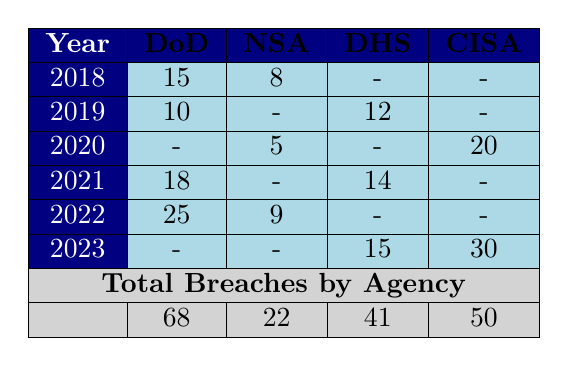What was the total number of cybersecurity breaches reported by the Department of Defense over the years from 2018 to 2023? To find the total breaches by the Department of Defense, we can sum the values across the rows for DoD: 15 (2018) + 10 (2019) + 18 (2021) + 25 (2022) = 68. There were no breaches reported for DoD in 2020 and 2023.
Answer: 68 How many breaches did the National Security Agency have in 2021? Looking at the row for 2021 in the NSA column, the value is 0, indicating that there were no breaches reported for the National Security Agency that year.
Answer: 0 In which year did the Cybersecurity and Infrastructure Security Agency report the highest number of breaches? The highest value in the CISA column is 30, which is reported in 2023. Thus, 2023 is the year with the highest breaches for this agency.
Answer: 2023 What is the average number of breaches reported by the Department of Homeland Security between 2019 and 2023? The total breaches for DHS are 12 (2019) + 14 (2021) + 15 (2023) = 41. There are three data points, so the average is 41/3 = 13.67.
Answer: 13.67 Did the National Security Agency report more breaches in 2022 compared to 2020? In 2022, the NSA reported 9 breaches; in 2020, they reported 5 breaches. Since 9 is greater than 5, the answer is yes.
Answer: Yes Which agency had the lowest total number of breaches from 2018 to 2023? The totals for each agency are: DoD 68, NSA 22, DHS 41, CISA 50. The National Security Agency had the lowest total with 22 breaches.
Answer: NSA What was the difference in the number of breaches reported by the Department of Defense between 2022 and 2021? In 2022, the Department of Defense reported 25 breaches and in 2021 they reported 18 breaches. The difference is 25 - 18 = 7.
Answer: 7 What is the total number of breaches reported across all agencies in 2020? In 2020, the totals are: NSA 5, CISA 20, and no breaches were reported by DoD or DHS. Thus, the total for that year is 5 + 20 = 25.
Answer: 25 